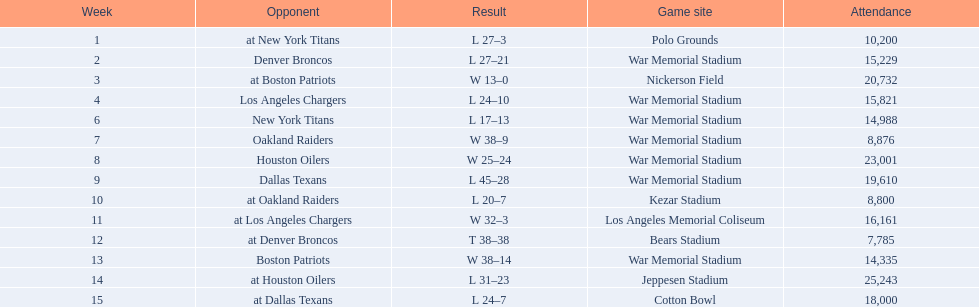How many times was war memorial stadium the game site? 6. 